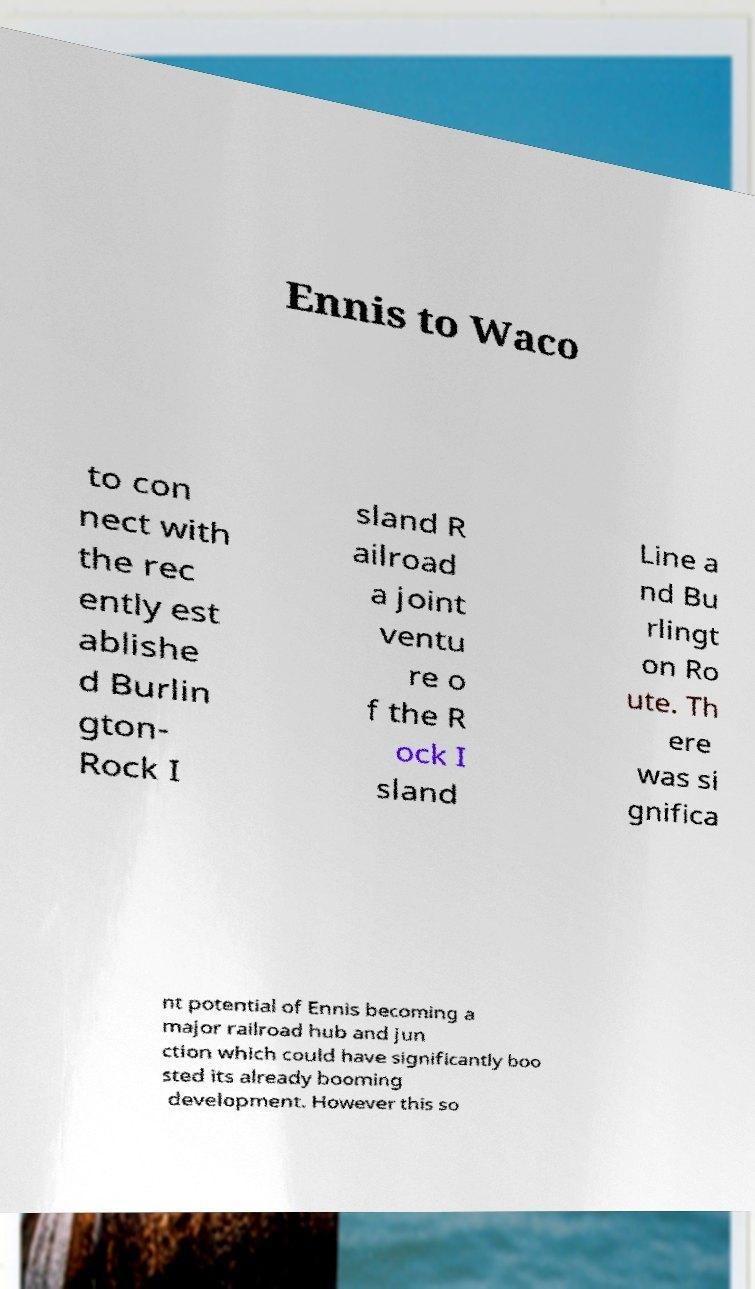Please read and relay the text visible in this image. What does it say? Ennis to Waco to con nect with the rec ently est ablishe d Burlin gton- Rock I sland R ailroad a joint ventu re o f the R ock I sland Line a nd Bu rlingt on Ro ute. Th ere was si gnifica nt potential of Ennis becoming a major railroad hub and jun ction which could have significantly boo sted its already booming development. However this so 